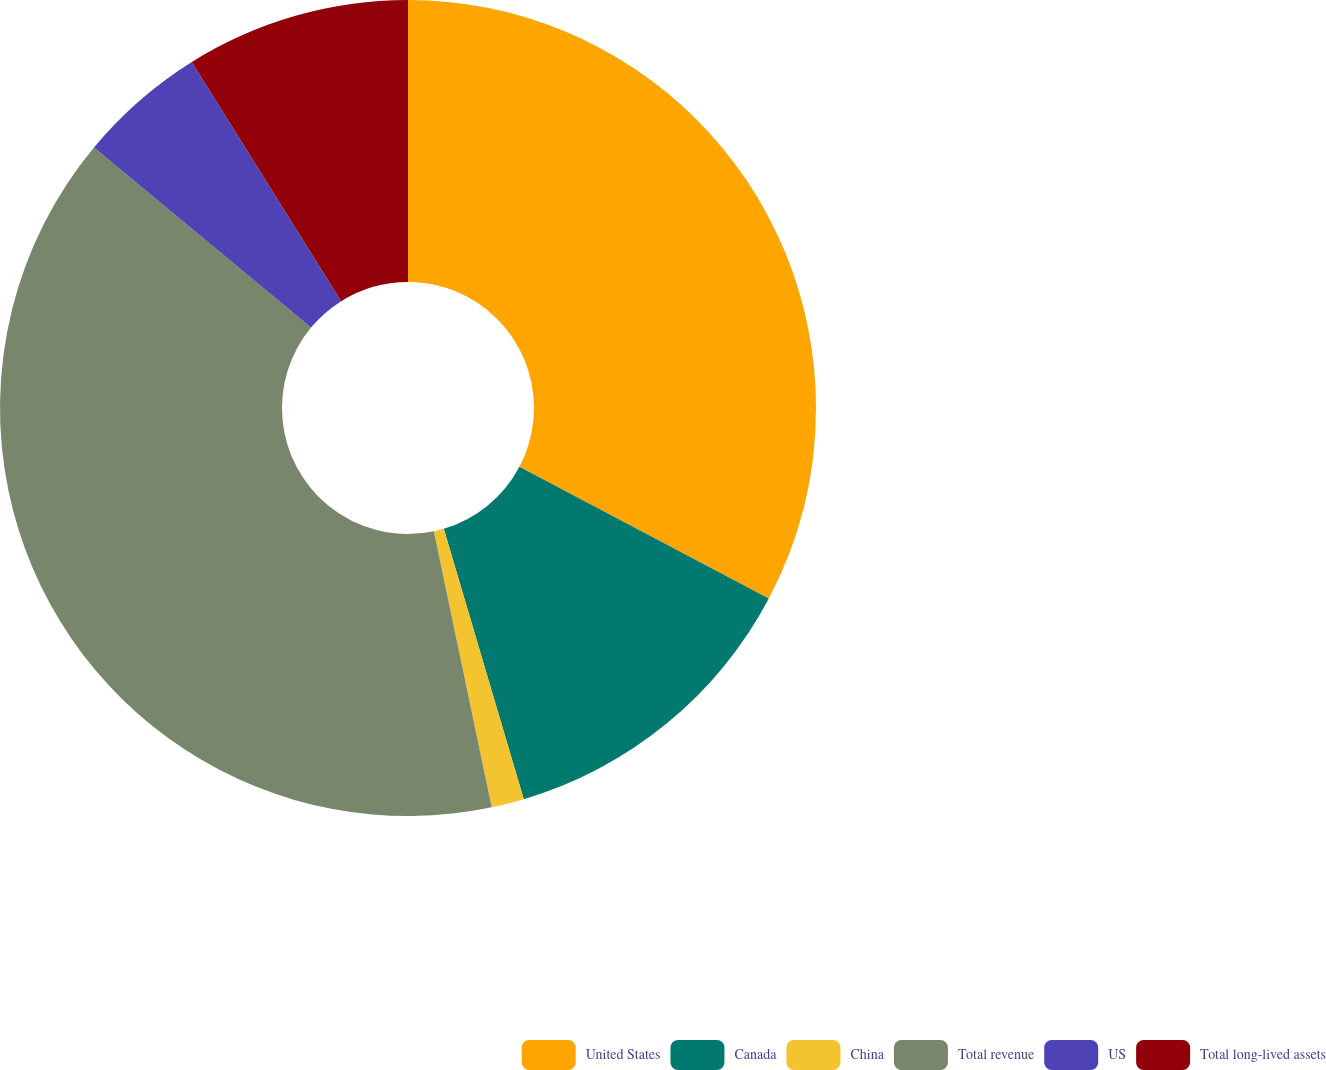<chart> <loc_0><loc_0><loc_500><loc_500><pie_chart><fcel>United States<fcel>Canada<fcel>China<fcel>Total revenue<fcel>US<fcel>Total long-lived assets<nl><fcel>32.73%<fcel>12.69%<fcel>1.29%<fcel>39.31%<fcel>5.09%<fcel>8.89%<nl></chart> 